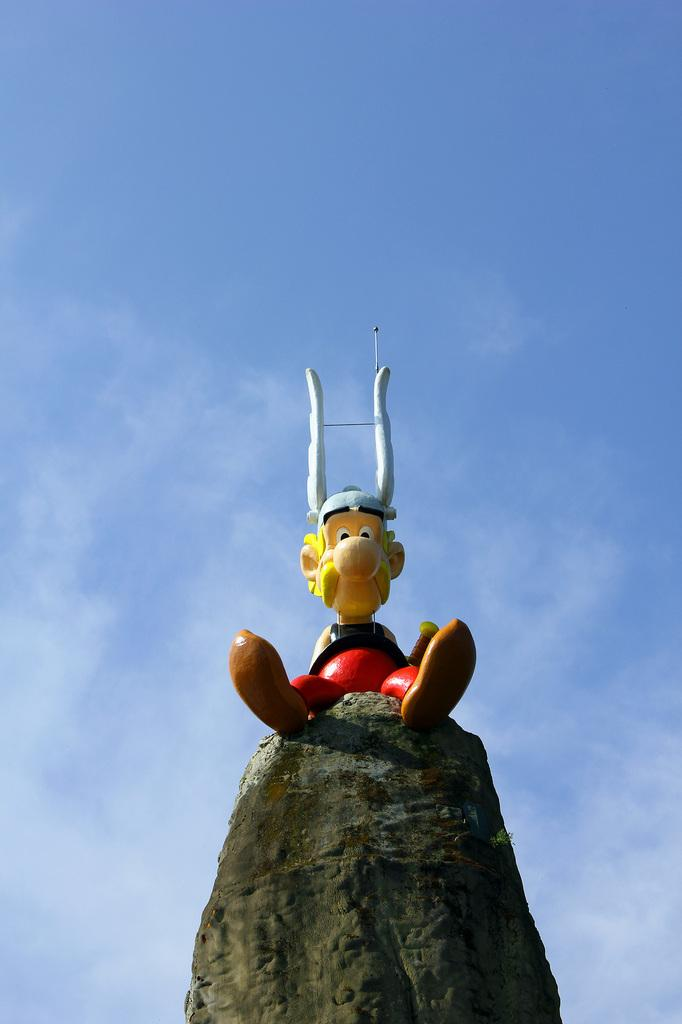What is the main subject of the image? There is a toy in the shape of a man in the image. Where is the toy located? The toy is on a rock. What color is the sky in the image? The sky is blue in the image. What type of needle is being used to sew the toy's part in the image? There is no needle or sewing activity present in the image. 